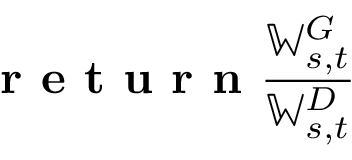Convert formula to latex. <formula><loc_0><loc_0><loc_500><loc_500>r e t u r n \frac { \mathbb { W } _ { s , t } ^ { G } } { \mathbb { W } _ { s , t } ^ { D } }</formula> 